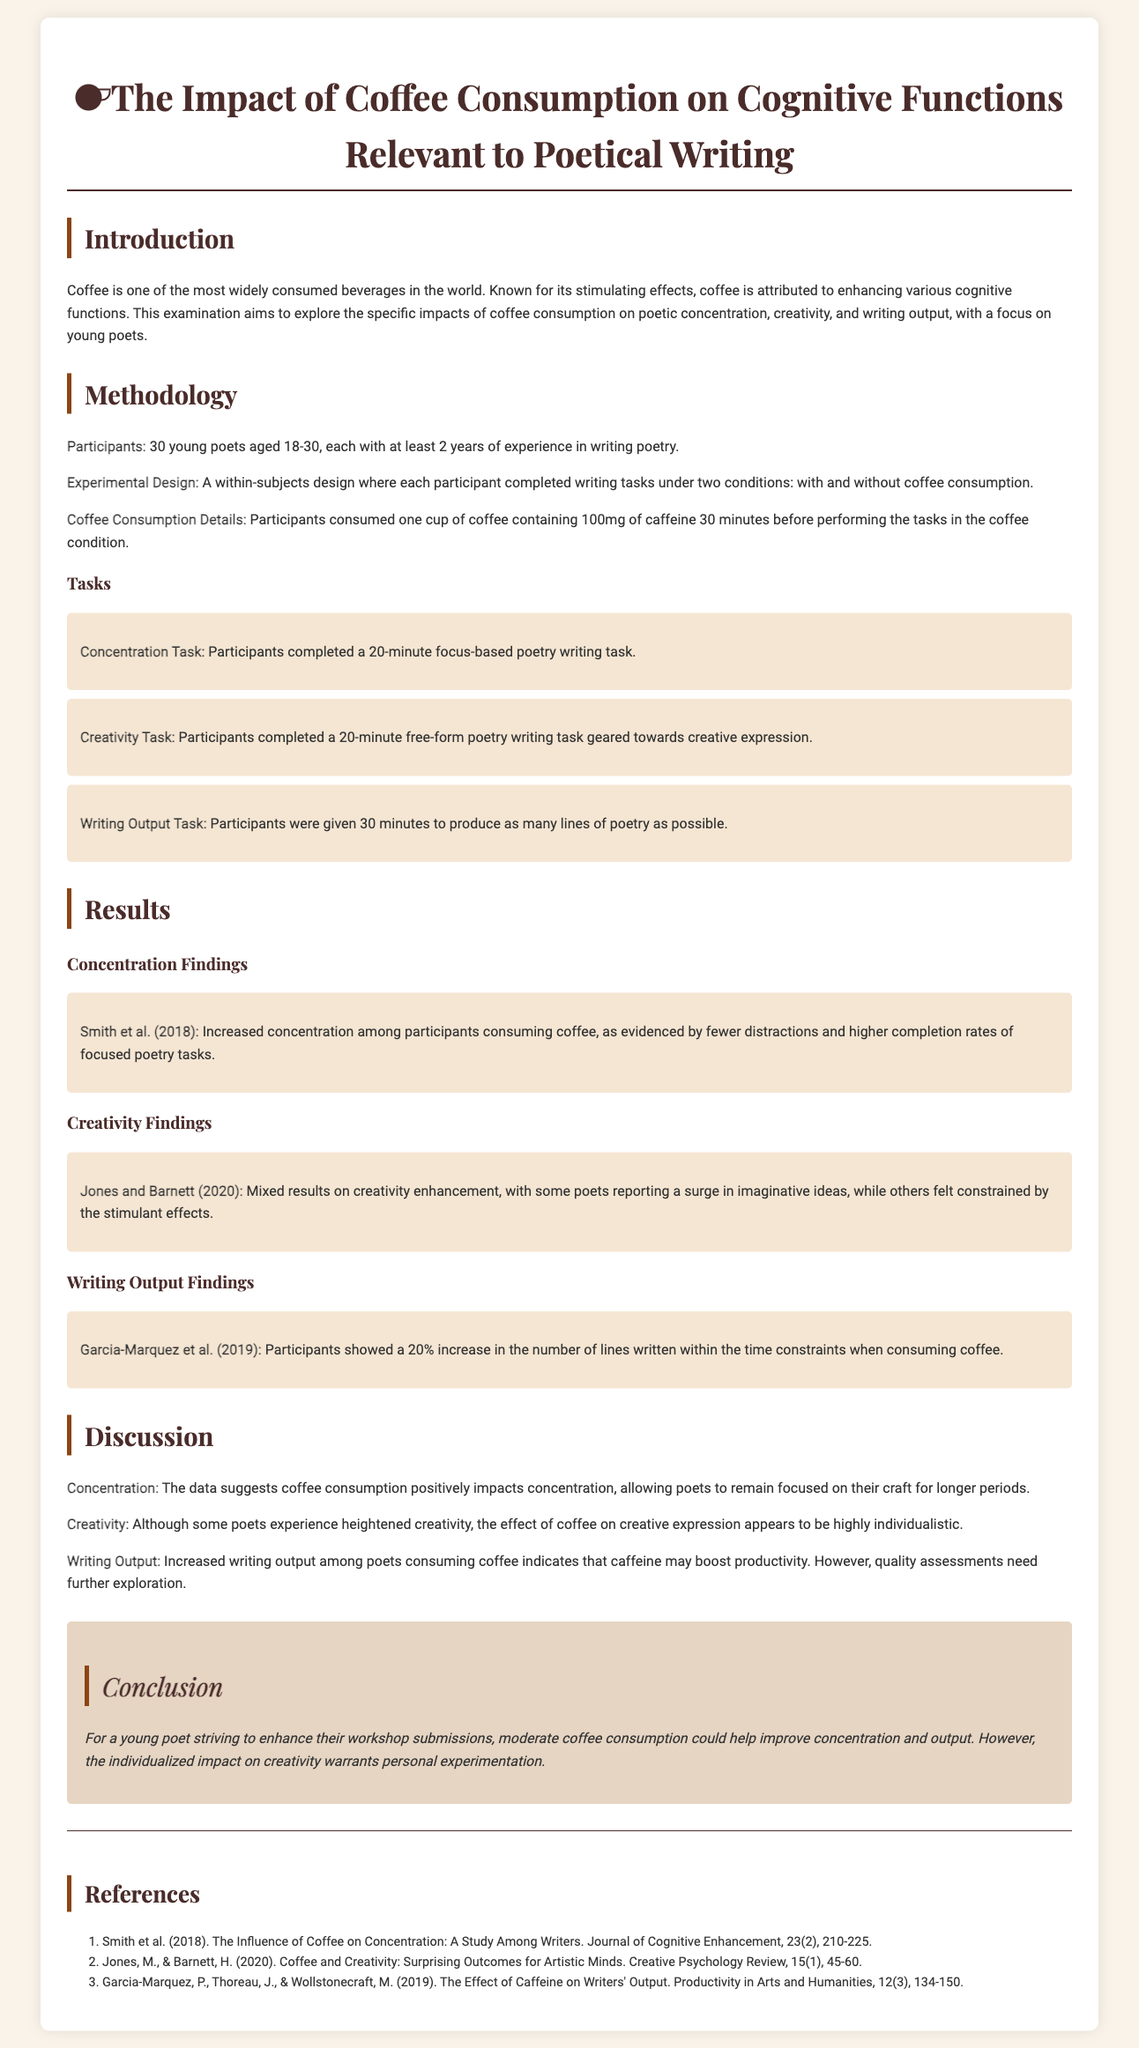What was the age range of participants? The participants were young poets aged 18-30, which indicates the specific age range of individuals involved in the study.
Answer: 18-30 What was the caffeine amount consumed by participants? Each participant consumed one cup of coffee containing 100mg of caffeine before performing the tasks, specifying the caffeine dosage used in the study.
Answer: 100mg How many writing tasks were participants required to complete? The number of writing tasks is explicitly mentioned in the document, detailing the structure of the experiment.
Answer: Three What was the increase in writing output measured in the study? The increase in writing output is quantified, providing a clear measurement of productivity effects among participants.
Answer: 20% Which two aspects of cognitive function were addressed in the creativity findings? The creativity findings discuss the differing effects of coffee on imaginative production and the perceptions of constraints, covering these two specific aspects.
Answer: Imaginative ideas, constraints What does the conclusion suggest about coffee consumption for young poets? The conclusion summarizes the key takeaway about coffee's potential benefits for young poets regarding their writing process.
Answer: Moderate coffee consumption What type of study design was used in this research? The study employed a within-subjects design, which indicates how participants interacted with both conditions of the experiment.
Answer: Within-subjects design What was the main focus of the examination? The main focus is outlined in the introduction, specifying the intent of the examination regarding coffee and poetic writing.
Answer: Cognitive functions relevant to poetical writing 